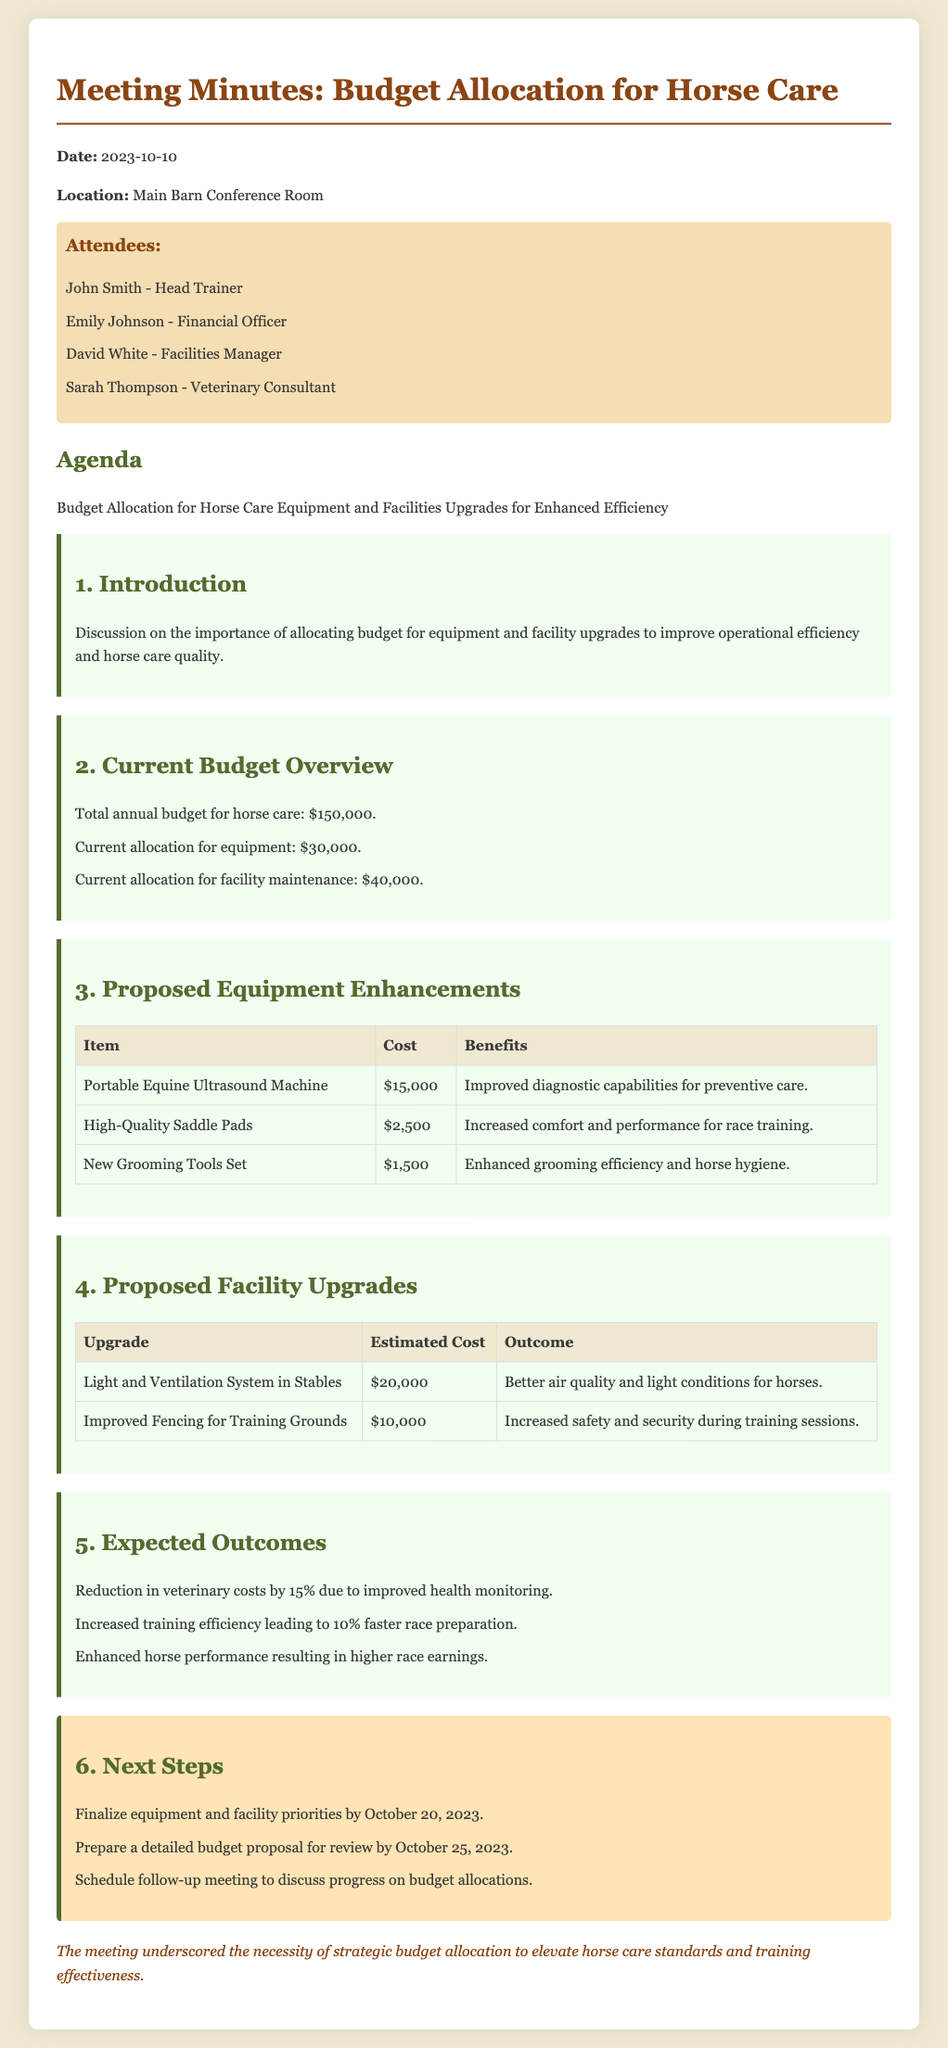What is the total annual budget for horse care? The total annual budget for horse care is stated in the document under the Current Budget Overview section.
Answer: $150,000 Who is the Financial Officer? The document lists attendees, including their roles. The Financial Officer is mentioned explicitly.
Answer: Emily Johnson What is the cost of the Portable Equine Ultrasound Machine? The cost of the Portable Equine Ultrasound Machine is mentioned in the Proposed Equipment Enhancements table.
Answer: $15,000 What outcome is expected from the improved fencing for training grounds? The expected outcome is stated in the Proposed Facility Upgrades section, specifically for the improved fencing.
Answer: Increased safety and security during training sessions When is the deadline to finalize equipment and facility priorities? The document provides specific deadlines in the Next Steps section for finalizing priorities.
Answer: October 20, 2023 How much reduction in veterinary costs is expected? The expected reduction in veterinary costs is listed in the Expected Outcomes section of the document.
Answer: 15% What is the benefit of high-quality saddle pads? The benefits of high-quality saddle pads are noted in the Proposed Equipment Enhancements table.
Answer: Increased comfort and performance for race training What is the proposed cost for the light and ventilation system in stables? The proposed cost is listed in the Proposed Facility Upgrades table under the relevant upgrade.
Answer: $20,000 